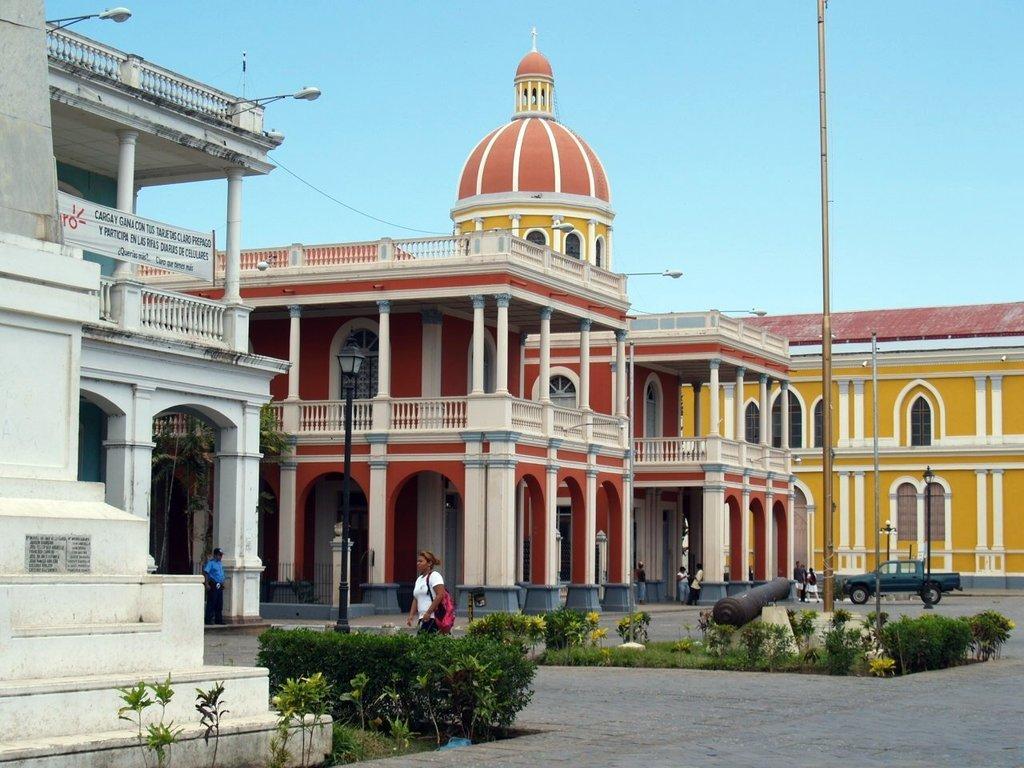How would you summarize this image in a sentence or two? Buildings with windows and pillars. Here we can see a banner above this fence. These are light poles. Here we can see planets, people, military weapon and vehicle. Sky is in blue color. 